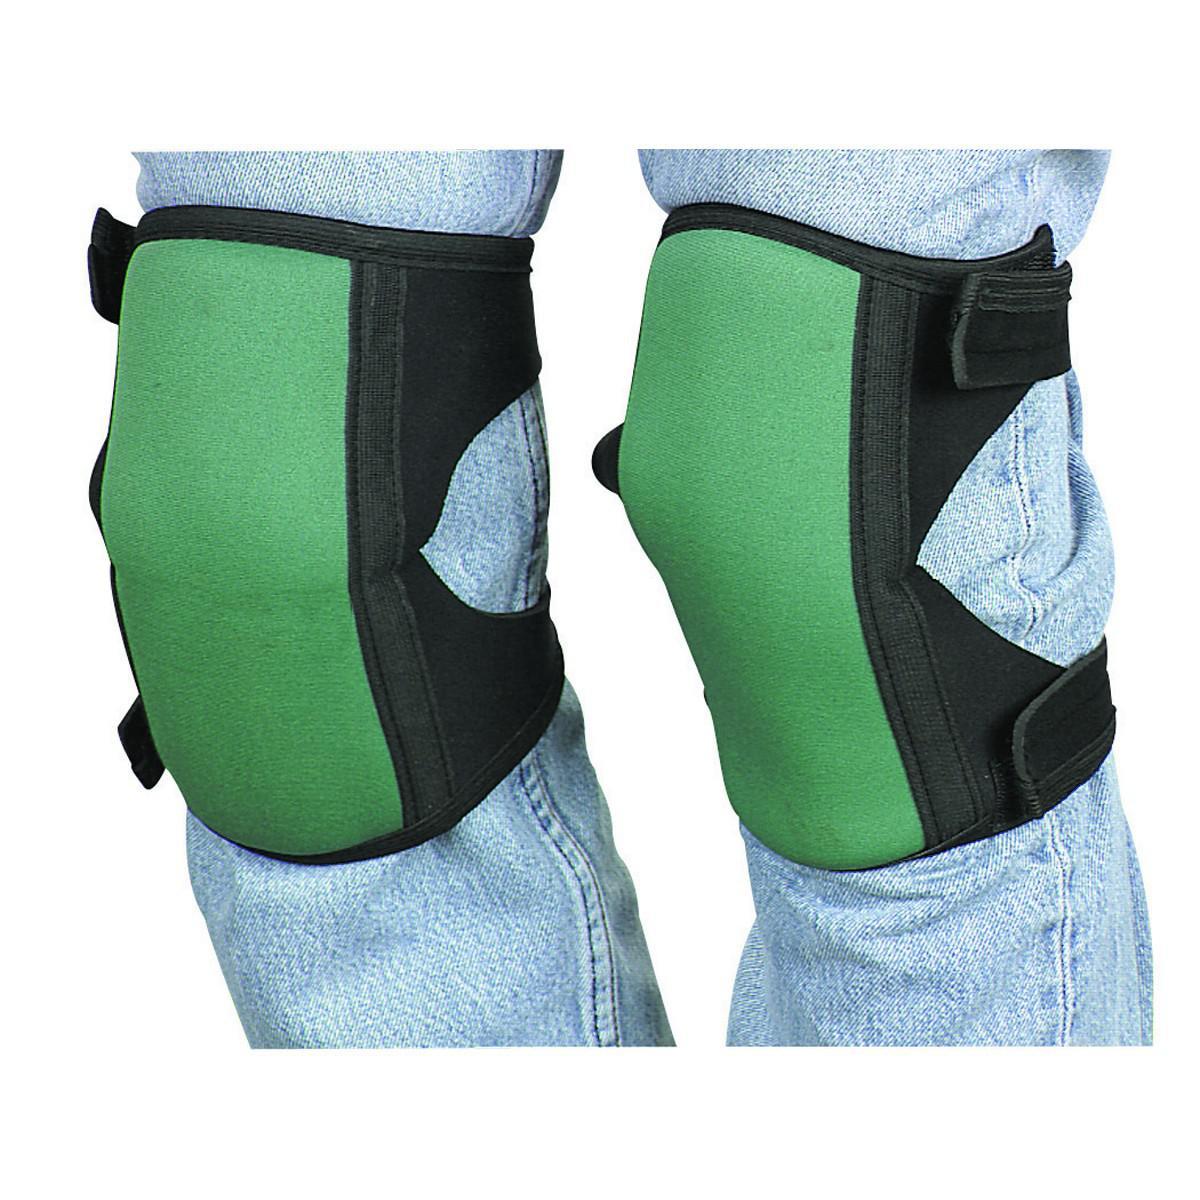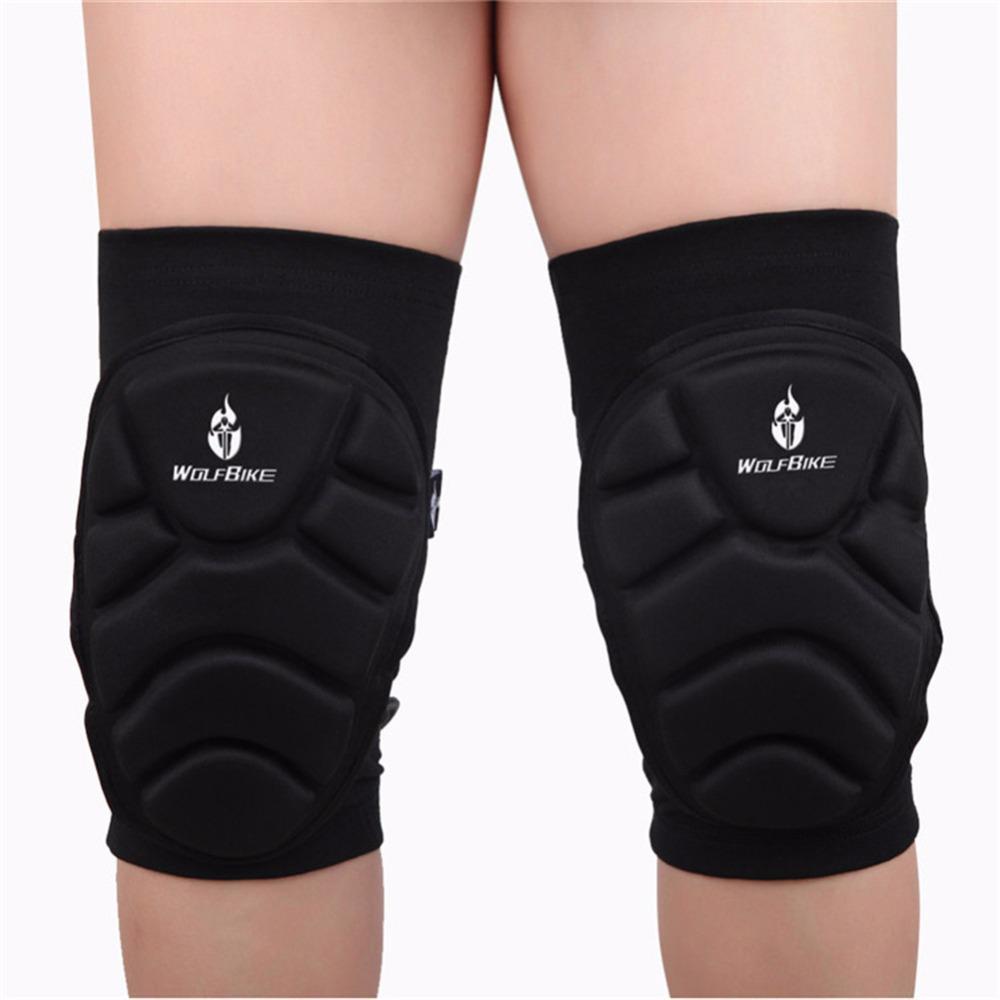The first image is the image on the left, the second image is the image on the right. Considering the images on both sides, is "Each image shows one pair of legs wearing a pair of knee pads." valid? Answer yes or no. Yes. The first image is the image on the left, the second image is the image on the right. Assess this claim about the two images: "There are four legs and four knee pads.". Correct or not? Answer yes or no. Yes. 